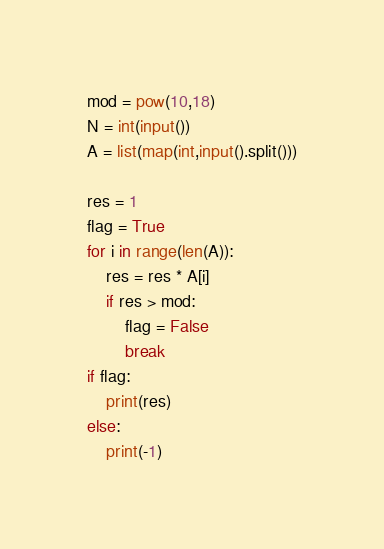Convert code to text. <code><loc_0><loc_0><loc_500><loc_500><_Python_>mod = pow(10,18)
N = int(input())
A = list(map(int,input().split()))

res = 1
flag = True
for i in range(len(A)):
    res = res * A[i]
    if res > mod:
        flag = False
        break
if flag:
    print(res)
else:
    print(-1)</code> 